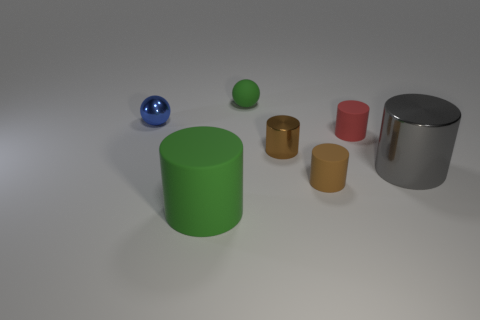What is the material of the tiny ball that is the same color as the big rubber object?
Give a very brief answer. Rubber. There is a tiny sphere that is on the right side of the big cylinder that is on the left side of the big gray metallic cylinder; is there a green matte sphere that is behind it?
Your answer should be compact. No. What number of cylinders are either small rubber objects or large gray metal things?
Your response must be concise. 3. There is a green thing in front of the small brown rubber thing; what material is it?
Provide a short and direct response. Rubber. What is the size of the matte sphere that is the same color as the large matte object?
Ensure brevity in your answer.  Small. Do the small shiny thing that is in front of the tiny red rubber cylinder and the small thing that is behind the tiny shiny ball have the same color?
Give a very brief answer. No. How many objects are small gray cylinders or green matte balls?
Provide a succinct answer. 1. How many other things are the same shape as the tiny brown matte object?
Keep it short and to the point. 4. Is the material of the cylinder that is on the right side of the red rubber object the same as the thing on the left side of the big green cylinder?
Make the answer very short. Yes. There is a small rubber thing that is in front of the tiny blue metallic sphere and behind the gray metallic cylinder; what is its shape?
Keep it short and to the point. Cylinder. 